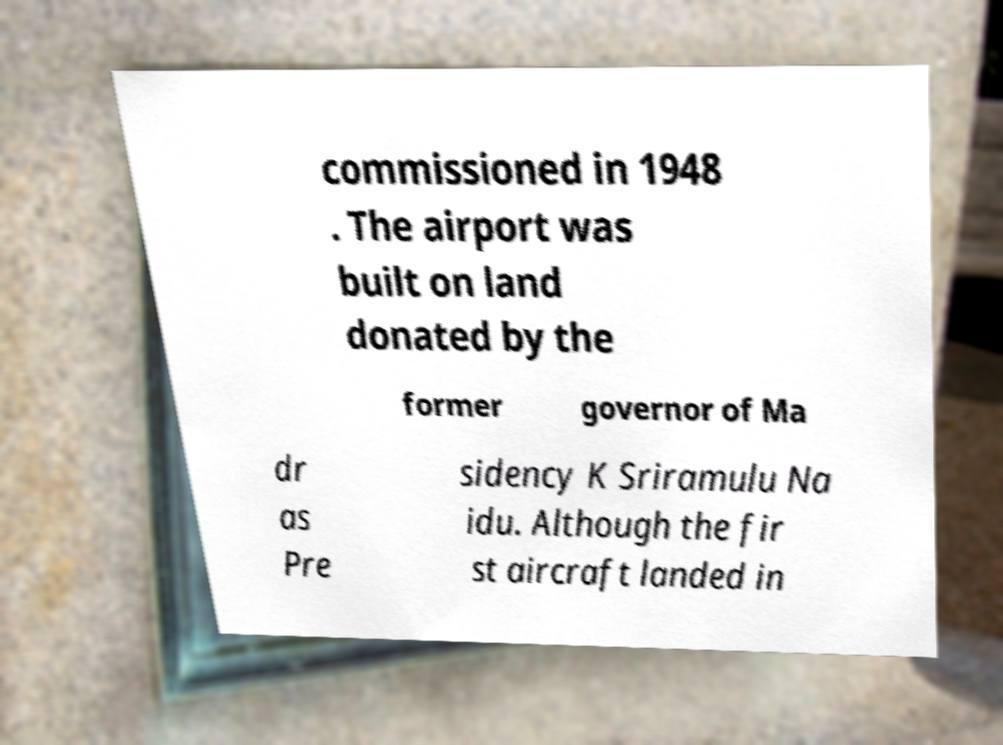For documentation purposes, I need the text within this image transcribed. Could you provide that? commissioned in 1948 . The airport was built on land donated by the former governor of Ma dr as Pre sidency K Sriramulu Na idu. Although the fir st aircraft landed in 